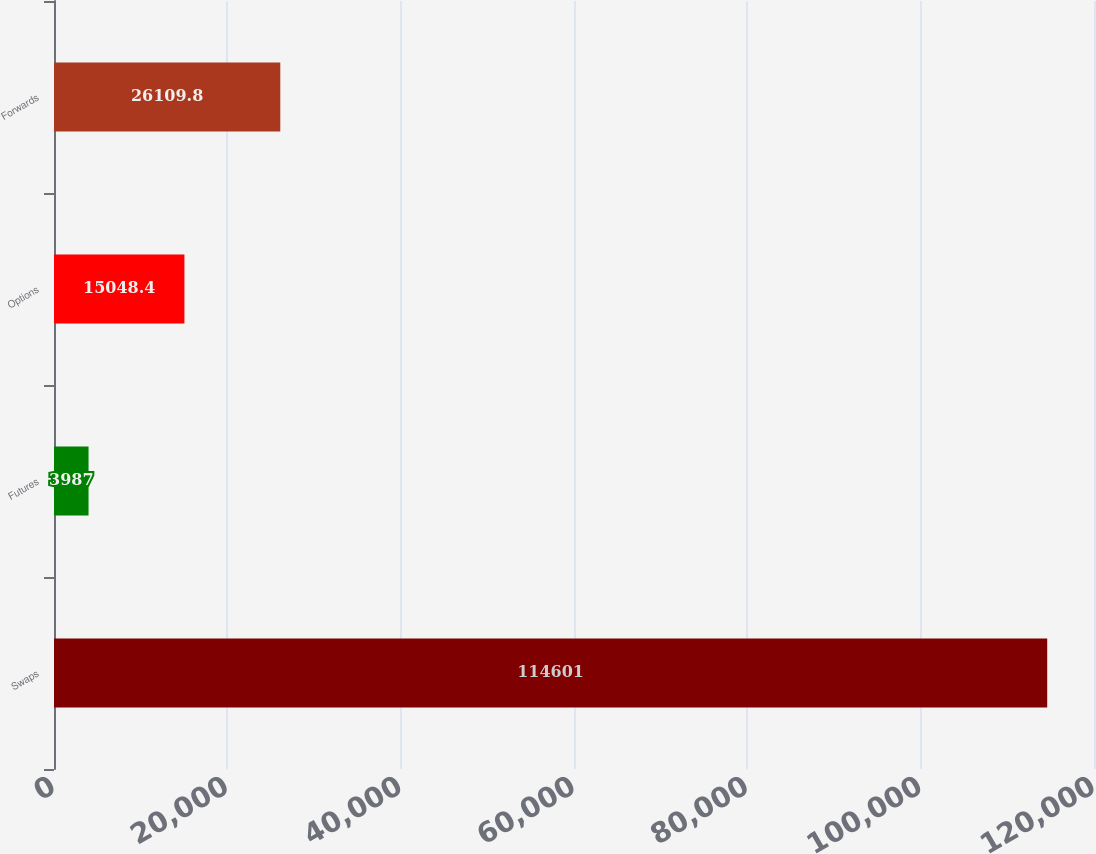Convert chart. <chart><loc_0><loc_0><loc_500><loc_500><bar_chart><fcel>Swaps<fcel>Futures<fcel>Options<fcel>Forwards<nl><fcel>114601<fcel>3987<fcel>15048.4<fcel>26109.8<nl></chart> 